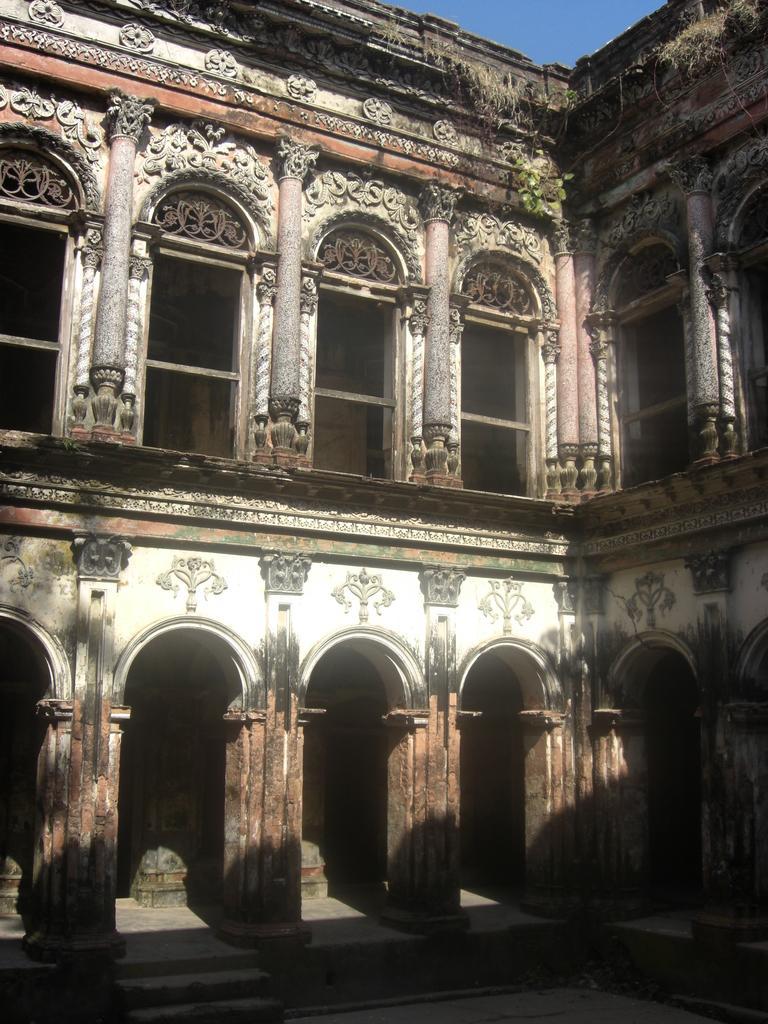Describe this image in one or two sentences. In this picture we can observe a building. there are pillars. The building is in white and brown color. In the background there is a sky. 